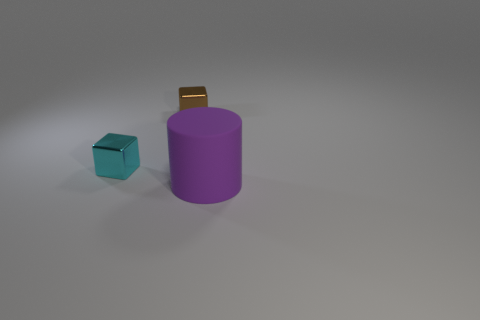There is a cyan object; is its shape the same as the tiny thing to the right of the cyan object?
Make the answer very short. Yes. What number of things are behind the purple cylinder and right of the tiny cyan thing?
Ensure brevity in your answer.  1. Is the cyan object made of the same material as the small block that is behind the tiny cyan cube?
Provide a succinct answer. Yes. Are there the same number of matte cylinders that are in front of the purple matte object and cyan things?
Keep it short and to the point. No. There is a metallic thing that is behind the cyan metal thing; what is its color?
Offer a very short reply. Brown. What number of other objects are the same color as the big cylinder?
Your answer should be very brief. 0. Are there any other things that have the same size as the cylinder?
Ensure brevity in your answer.  No. Is the size of the metal cube that is in front of the brown shiny thing the same as the brown metallic object?
Provide a short and direct response. Yes. There is a cube on the left side of the tiny brown object; what is it made of?
Your response must be concise. Metal. Is there anything else that is the same shape as the purple matte object?
Ensure brevity in your answer.  No. 